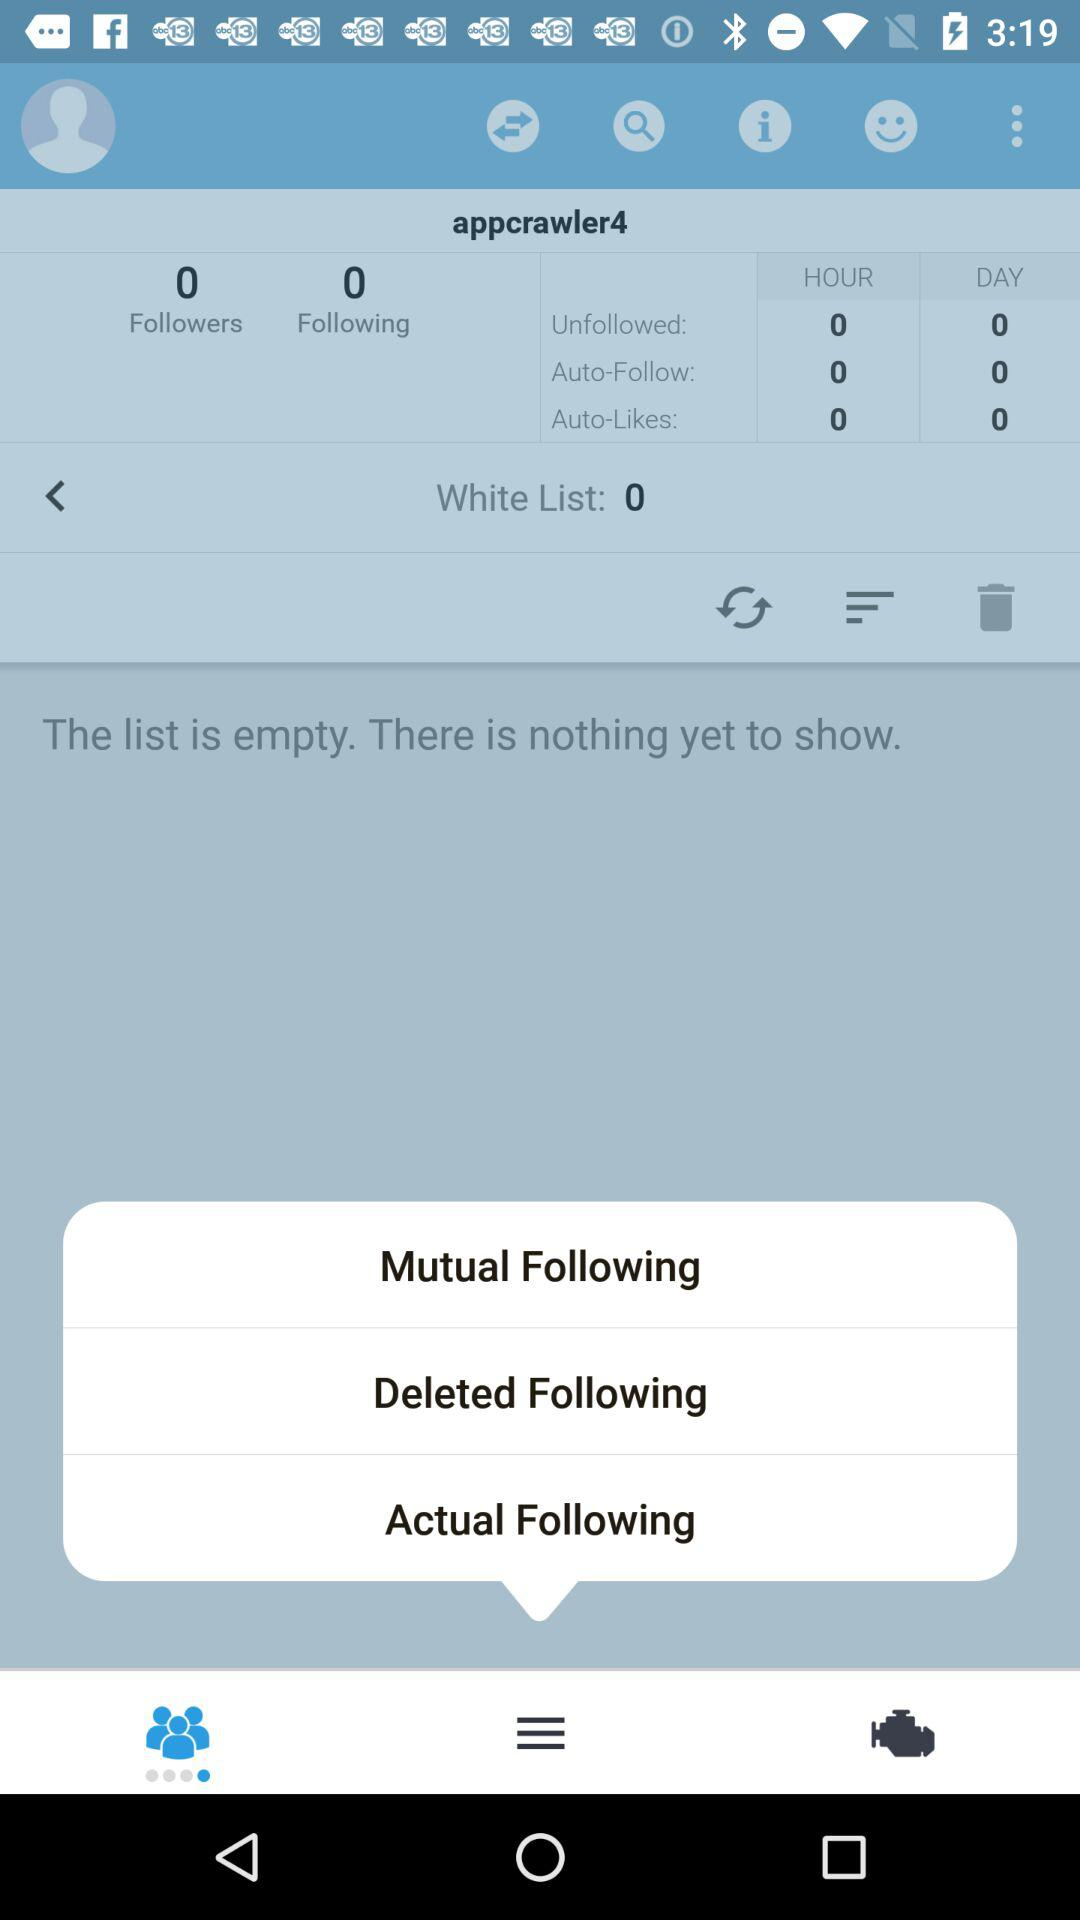What is the username? The username is "appcrawler4". 